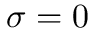Convert formula to latex. <formula><loc_0><loc_0><loc_500><loc_500>\sigma = 0</formula> 